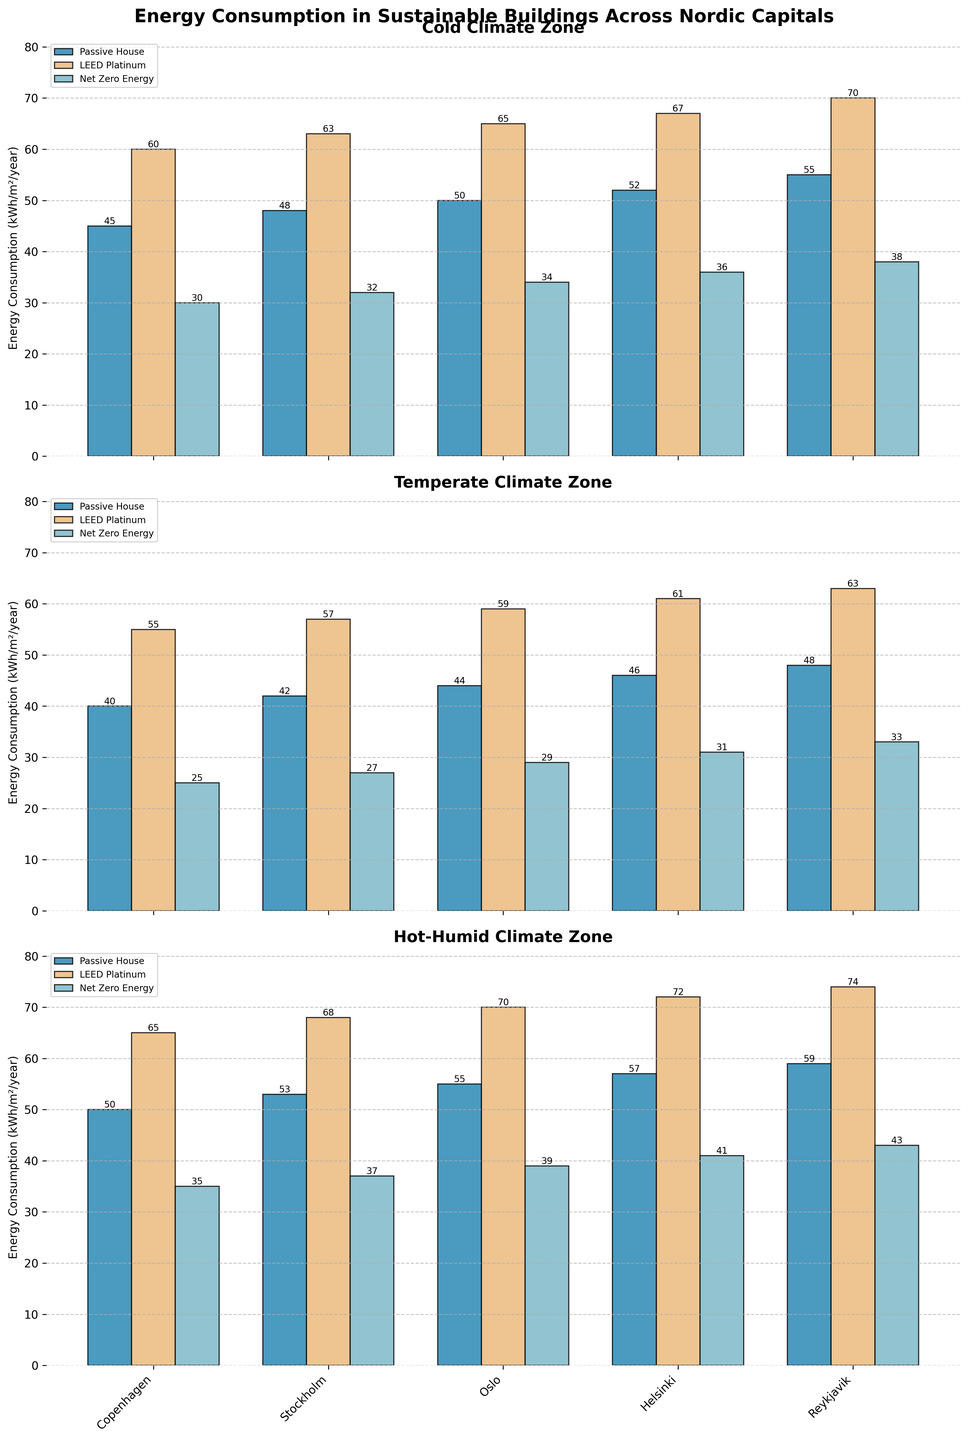What is the average energy consumption for Passive House buildings in Cold climate zones? Sum the values for Passive House in Cold climate zones: (45+48+50+52+55) = 250. Divide by the number of cities (5): 250/5 = 50
Answer: 50 Which city has the highest energy consumption for Net Zero Energy buildings in the Temperate climate zone? Compare the energy consumption for Net Zero Energy buildings in each city within the Temperate climate zone: Copenhagen (25), Stockholm (27), Oslo (29), Helsinki (31), Reykjavik (33). The highest value is 33 in Reykjavik.
Answer: Reykjavik What is the difference in energy consumption between LEED Platinum and Net Zero Energy buildings in Helsinki for the Hot-Humid climate zone? Subtract the energy consumption for Net Zero Energy (41) from LEED Platinum (72) in Helsinki: 72 - 41 = 31
Answer: 31 Which building type uses the least energy in the Temperate climate zone overall? Compare the total energy consumption across all cities for each building type: Passive House (40+42+44+46+48), LEED Platinum (55+57+59+61+63), Net Zero Energy (25+27+29+31+33). The lowest sum is 145 for Net Zero Energy.
Answer: Net Zero Energy How does the energy consumption for LEED Platinum buildings in Oslo compare between Cold and Hot-Humid climate zones? Compare the energy consumption for LEED Platinum in Oslo: Cold (65), Hot-Humid (70). LEED Platinum uses more energy in Hot-Humid climate zones.
Answer: Higher in Hot-Humid What is the total energy consumption for all building types combined in Copenhagen? Sum the values for all building types in Copenhagen: Cold (45+60+30), Temperate (40+55+25), Hot-Humid (50+65+35). Total = 45+60+30+40+55+25+50+65+35 = 405.
Answer: 405 In which city do Passive House buildings have the lowest energy consumption in the Hot-Humid climate zone? Compare the energy consumption for Passive House buildings in the Hot-Humid climate zone: Copenhagen (50), Stockholm (53), Oslo (55), Helsinki (57), Reykjavik (59). The lowest value is 50 in Copenhagen.
Answer: Copenhagen Does Reykjavik have higher energy consumption for LEED Platinum buildings in Cold or Temperate climate zones? Compare the consumption for LEED Platinum in Reykjavik for Cold (70) and Temperate (63) climate zones. 70 is higher than 63.
Answer: Cold Which climate zone experiences the least variation in energy consumption for Net Zero Energy buildings across all cities? Calculate the range (max - min) of energy consumption for Net Zero Energy buildings in each climate zone: Cold (38-30), Temperate (33-25), Hot-Humid (43-35). The smallest range is 8 for Cold.
Answer: Cold 